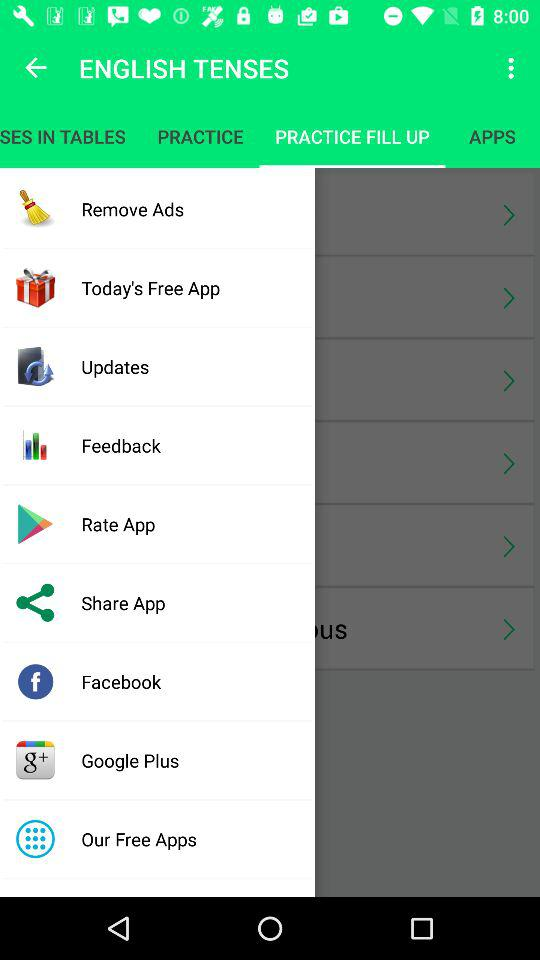Which tab is selected? The selected tab is "PRACTICE FILL UP". 